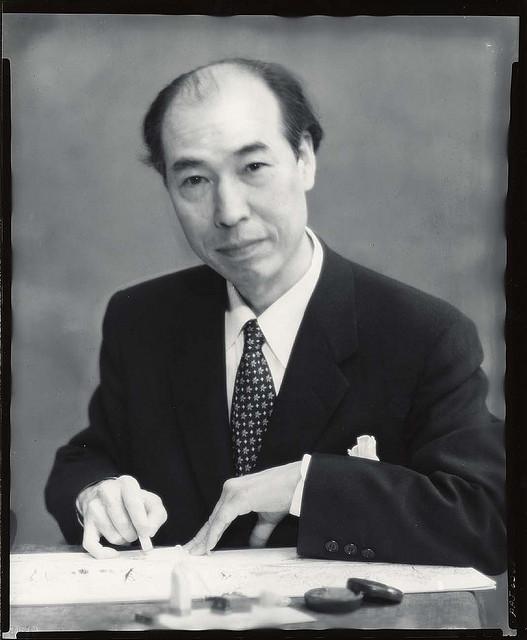What color is the man's suit?
Write a very short answer. Black. What pattern is on his tie?
Write a very short answer. Stars. What is the item typed at man's shirt collar?
Give a very brief answer. Tie. What country is this man likely in?
Short answer required. China. Is the man balding?
Quick response, please. Yes. What is the man wearing?
Quick response, please. Suit. 